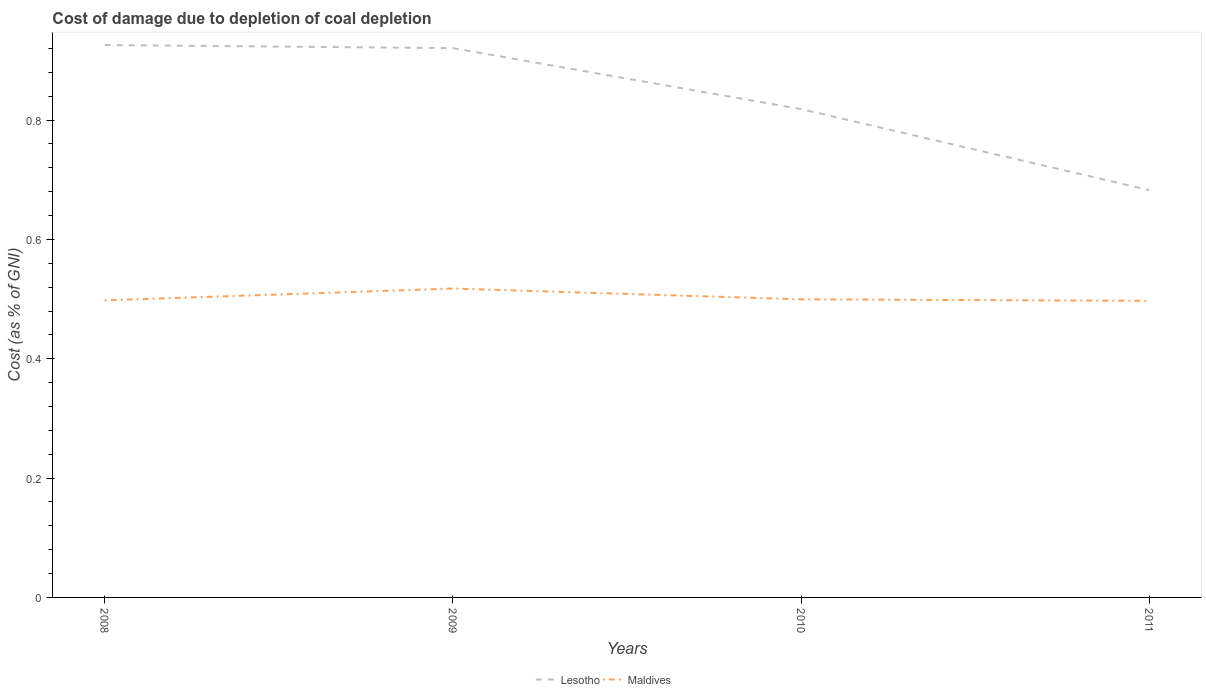Does the line corresponding to Lesotho intersect with the line corresponding to Maldives?
Your answer should be very brief. No. Across all years, what is the maximum cost of damage caused due to coal depletion in Maldives?
Offer a very short reply. 0.5. In which year was the cost of damage caused due to coal depletion in Lesotho maximum?
Provide a succinct answer. 2011. What is the total cost of damage caused due to coal depletion in Maldives in the graph?
Keep it short and to the point. 0. What is the difference between the highest and the second highest cost of damage caused due to coal depletion in Maldives?
Offer a terse response. 0.02. Is the cost of damage caused due to coal depletion in Maldives strictly greater than the cost of damage caused due to coal depletion in Lesotho over the years?
Your answer should be very brief. Yes. How many years are there in the graph?
Make the answer very short. 4. How are the legend labels stacked?
Make the answer very short. Horizontal. What is the title of the graph?
Make the answer very short. Cost of damage due to depletion of coal depletion. Does "Libya" appear as one of the legend labels in the graph?
Offer a very short reply. No. What is the label or title of the Y-axis?
Your answer should be very brief. Cost (as % of GNI). What is the Cost (as % of GNI) of Lesotho in 2008?
Make the answer very short. 0.93. What is the Cost (as % of GNI) in Maldives in 2008?
Keep it short and to the point. 0.5. What is the Cost (as % of GNI) in Lesotho in 2009?
Ensure brevity in your answer.  0.92. What is the Cost (as % of GNI) of Maldives in 2009?
Your answer should be very brief. 0.52. What is the Cost (as % of GNI) of Lesotho in 2010?
Offer a very short reply. 0.82. What is the Cost (as % of GNI) in Maldives in 2010?
Make the answer very short. 0.5. What is the Cost (as % of GNI) in Lesotho in 2011?
Your answer should be very brief. 0.68. What is the Cost (as % of GNI) of Maldives in 2011?
Ensure brevity in your answer.  0.5. Across all years, what is the maximum Cost (as % of GNI) in Lesotho?
Your answer should be very brief. 0.93. Across all years, what is the maximum Cost (as % of GNI) of Maldives?
Keep it short and to the point. 0.52. Across all years, what is the minimum Cost (as % of GNI) of Lesotho?
Provide a succinct answer. 0.68. Across all years, what is the minimum Cost (as % of GNI) in Maldives?
Ensure brevity in your answer.  0.5. What is the total Cost (as % of GNI) of Lesotho in the graph?
Offer a terse response. 3.35. What is the total Cost (as % of GNI) in Maldives in the graph?
Keep it short and to the point. 2.01. What is the difference between the Cost (as % of GNI) in Lesotho in 2008 and that in 2009?
Your answer should be very brief. 0.01. What is the difference between the Cost (as % of GNI) of Maldives in 2008 and that in 2009?
Ensure brevity in your answer.  -0.02. What is the difference between the Cost (as % of GNI) in Lesotho in 2008 and that in 2010?
Offer a very short reply. 0.11. What is the difference between the Cost (as % of GNI) in Maldives in 2008 and that in 2010?
Your answer should be compact. -0. What is the difference between the Cost (as % of GNI) in Lesotho in 2008 and that in 2011?
Your answer should be very brief. 0.24. What is the difference between the Cost (as % of GNI) of Maldives in 2008 and that in 2011?
Provide a short and direct response. 0. What is the difference between the Cost (as % of GNI) of Lesotho in 2009 and that in 2010?
Make the answer very short. 0.1. What is the difference between the Cost (as % of GNI) of Maldives in 2009 and that in 2010?
Provide a short and direct response. 0.02. What is the difference between the Cost (as % of GNI) of Lesotho in 2009 and that in 2011?
Your answer should be compact. 0.24. What is the difference between the Cost (as % of GNI) in Maldives in 2009 and that in 2011?
Ensure brevity in your answer.  0.02. What is the difference between the Cost (as % of GNI) of Lesotho in 2010 and that in 2011?
Keep it short and to the point. 0.14. What is the difference between the Cost (as % of GNI) of Maldives in 2010 and that in 2011?
Offer a terse response. 0. What is the difference between the Cost (as % of GNI) in Lesotho in 2008 and the Cost (as % of GNI) in Maldives in 2009?
Your answer should be very brief. 0.41. What is the difference between the Cost (as % of GNI) in Lesotho in 2008 and the Cost (as % of GNI) in Maldives in 2010?
Offer a very short reply. 0.43. What is the difference between the Cost (as % of GNI) in Lesotho in 2008 and the Cost (as % of GNI) in Maldives in 2011?
Offer a very short reply. 0.43. What is the difference between the Cost (as % of GNI) of Lesotho in 2009 and the Cost (as % of GNI) of Maldives in 2010?
Your answer should be compact. 0.42. What is the difference between the Cost (as % of GNI) in Lesotho in 2009 and the Cost (as % of GNI) in Maldives in 2011?
Your response must be concise. 0.42. What is the difference between the Cost (as % of GNI) in Lesotho in 2010 and the Cost (as % of GNI) in Maldives in 2011?
Your answer should be compact. 0.32. What is the average Cost (as % of GNI) in Lesotho per year?
Offer a terse response. 0.84. What is the average Cost (as % of GNI) of Maldives per year?
Provide a short and direct response. 0.5. In the year 2008, what is the difference between the Cost (as % of GNI) of Lesotho and Cost (as % of GNI) of Maldives?
Make the answer very short. 0.43. In the year 2009, what is the difference between the Cost (as % of GNI) of Lesotho and Cost (as % of GNI) of Maldives?
Provide a succinct answer. 0.4. In the year 2010, what is the difference between the Cost (as % of GNI) in Lesotho and Cost (as % of GNI) in Maldives?
Give a very brief answer. 0.32. In the year 2011, what is the difference between the Cost (as % of GNI) of Lesotho and Cost (as % of GNI) of Maldives?
Offer a very short reply. 0.19. What is the ratio of the Cost (as % of GNI) in Lesotho in 2008 to that in 2009?
Make the answer very short. 1.01. What is the ratio of the Cost (as % of GNI) in Maldives in 2008 to that in 2009?
Give a very brief answer. 0.96. What is the ratio of the Cost (as % of GNI) of Lesotho in 2008 to that in 2010?
Your response must be concise. 1.13. What is the ratio of the Cost (as % of GNI) of Lesotho in 2008 to that in 2011?
Offer a very short reply. 1.36. What is the ratio of the Cost (as % of GNI) in Lesotho in 2009 to that in 2010?
Provide a short and direct response. 1.12. What is the ratio of the Cost (as % of GNI) of Maldives in 2009 to that in 2010?
Provide a succinct answer. 1.04. What is the ratio of the Cost (as % of GNI) in Lesotho in 2009 to that in 2011?
Ensure brevity in your answer.  1.35. What is the ratio of the Cost (as % of GNI) of Maldives in 2009 to that in 2011?
Your answer should be compact. 1.04. What is the ratio of the Cost (as % of GNI) in Lesotho in 2010 to that in 2011?
Your answer should be compact. 1.2. What is the ratio of the Cost (as % of GNI) of Maldives in 2010 to that in 2011?
Offer a terse response. 1. What is the difference between the highest and the second highest Cost (as % of GNI) of Lesotho?
Provide a short and direct response. 0.01. What is the difference between the highest and the second highest Cost (as % of GNI) in Maldives?
Provide a short and direct response. 0.02. What is the difference between the highest and the lowest Cost (as % of GNI) in Lesotho?
Your answer should be very brief. 0.24. What is the difference between the highest and the lowest Cost (as % of GNI) in Maldives?
Give a very brief answer. 0.02. 